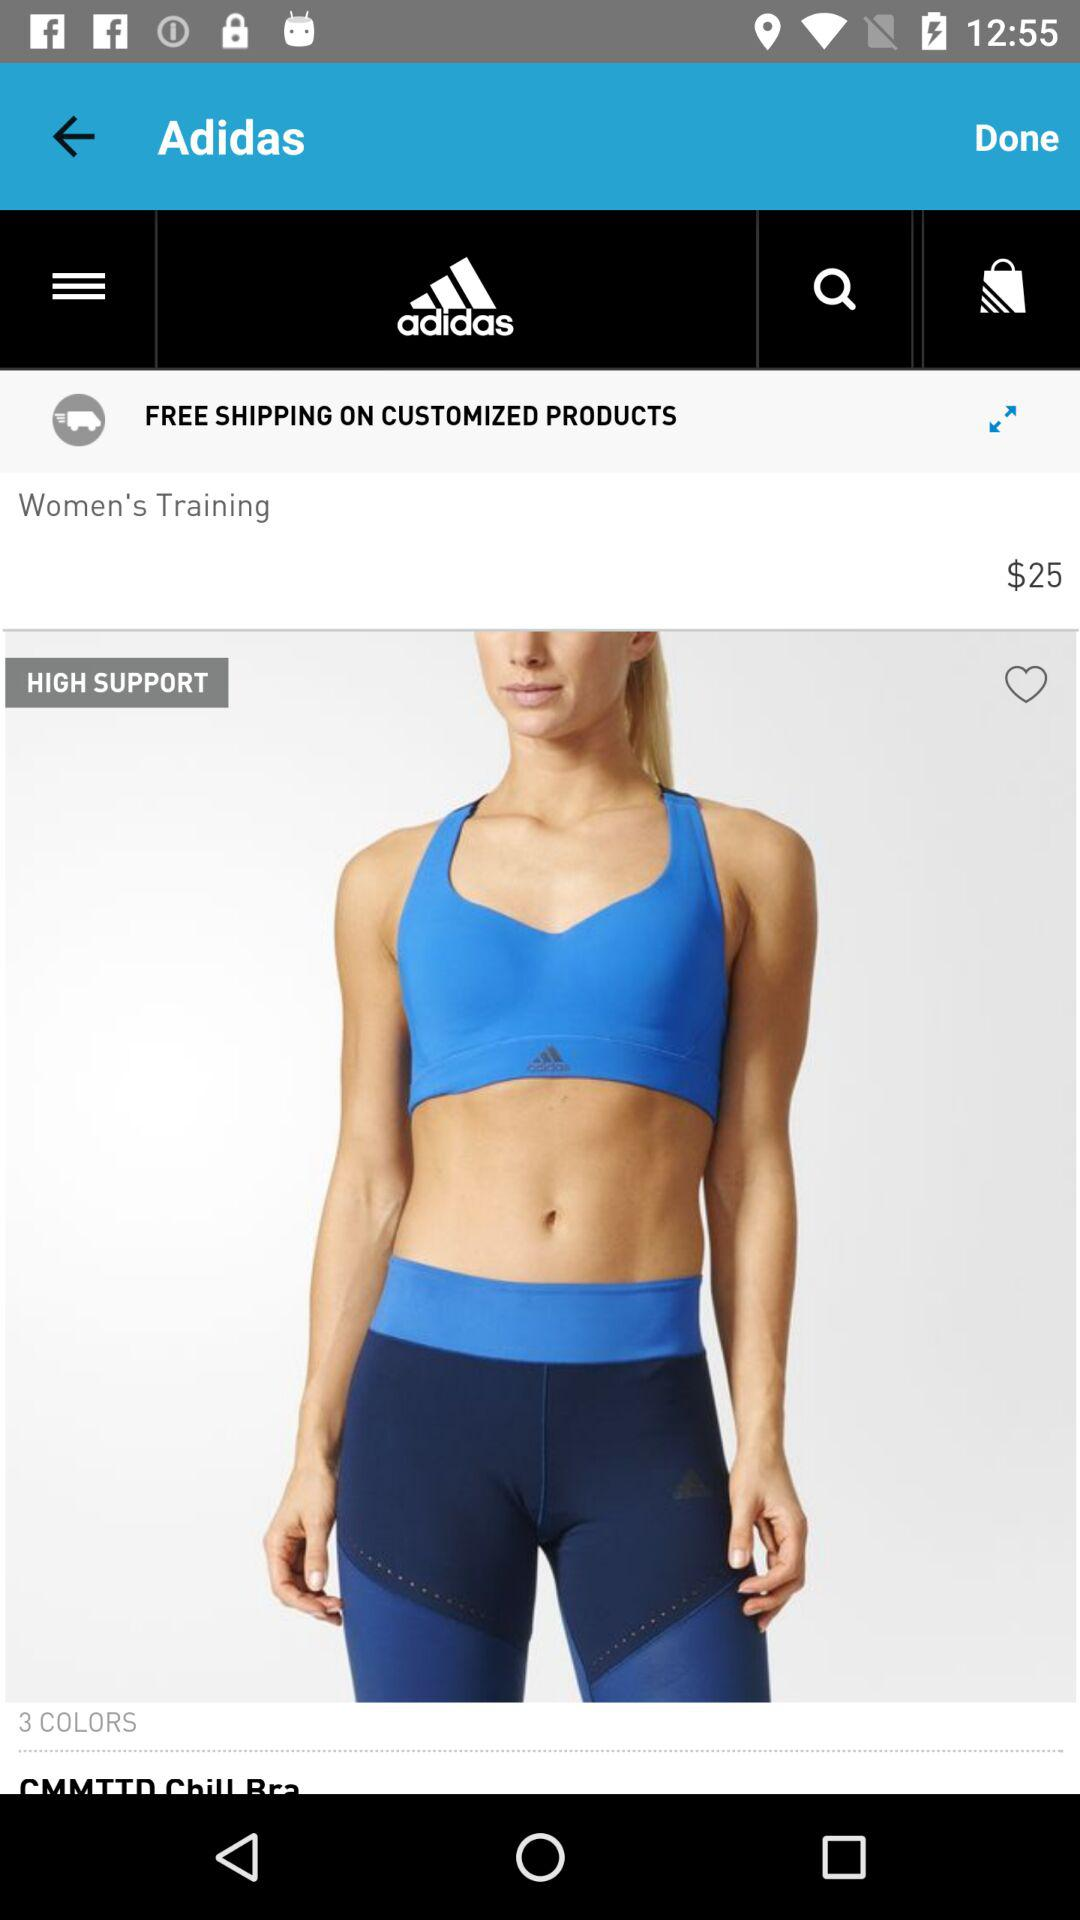How much is the CMMTTD Chill Bra?
Answer the question using a single word or phrase. $25 